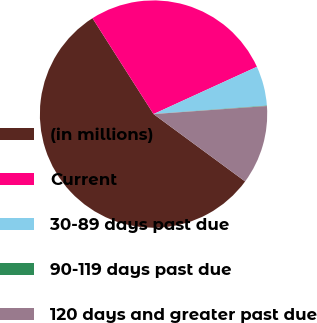Convert chart to OTSL. <chart><loc_0><loc_0><loc_500><loc_500><pie_chart><fcel>(in millions)<fcel>Current<fcel>30-89 days past due<fcel>90-119 days past due<fcel>120 days and greater past due<nl><fcel>55.89%<fcel>27.2%<fcel>5.64%<fcel>0.06%<fcel>11.22%<nl></chart> 